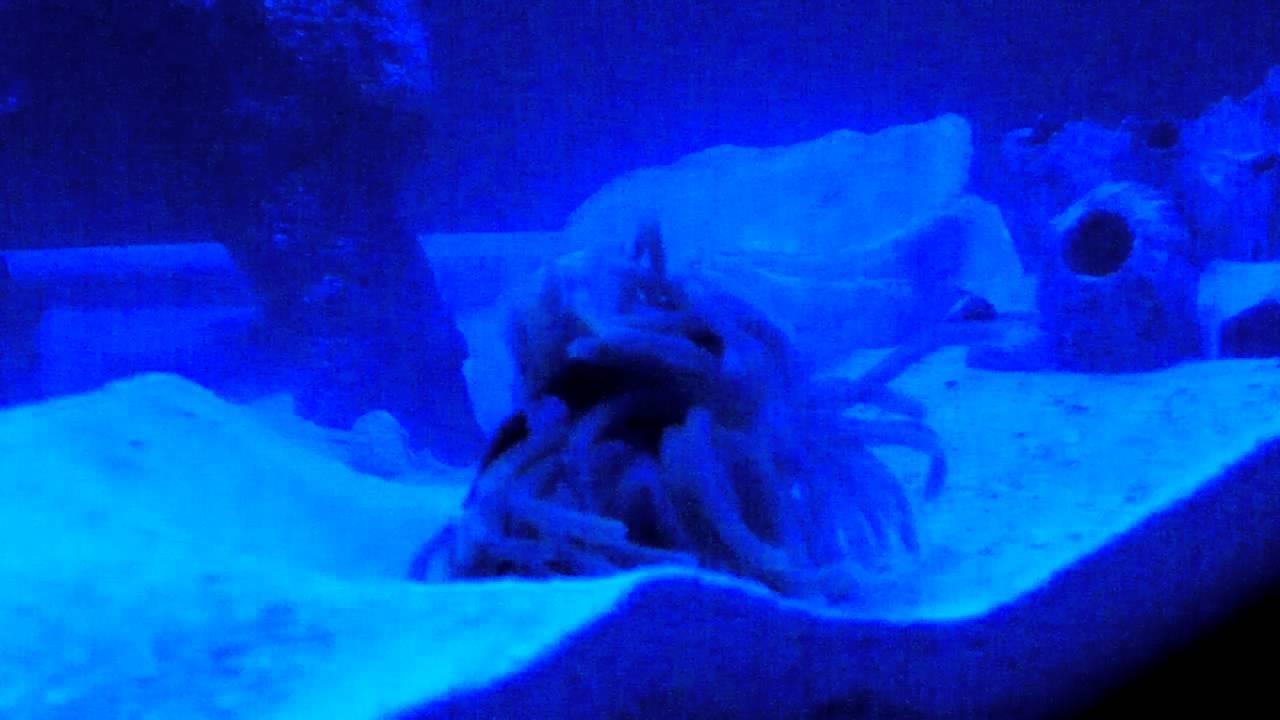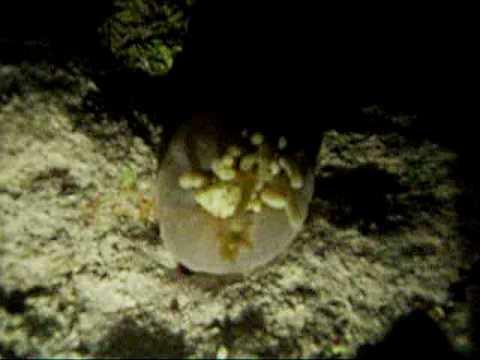The first image is the image on the left, the second image is the image on the right. Considering the images on both sides, is "At least one image features a striped fish atop a purplish-blue anemone." valid? Answer yes or no. No. The first image is the image on the left, the second image is the image on the right. For the images shown, is this caption "In both pictures a clownfish is swimming in a sea anemone." true? Answer yes or no. No. 